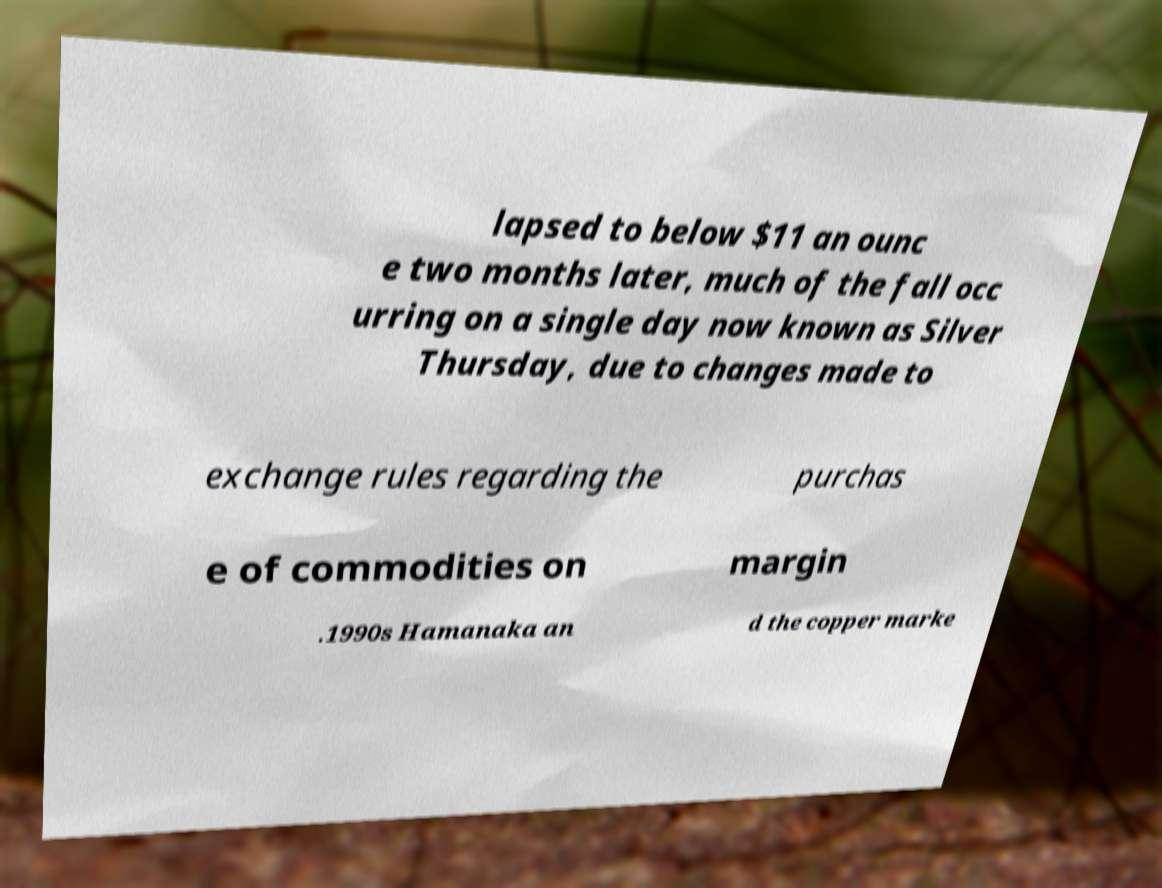Can you read and provide the text displayed in the image?This photo seems to have some interesting text. Can you extract and type it out for me? lapsed to below $11 an ounc e two months later, much of the fall occ urring on a single day now known as Silver Thursday, due to changes made to exchange rules regarding the purchas e of commodities on margin .1990s Hamanaka an d the copper marke 